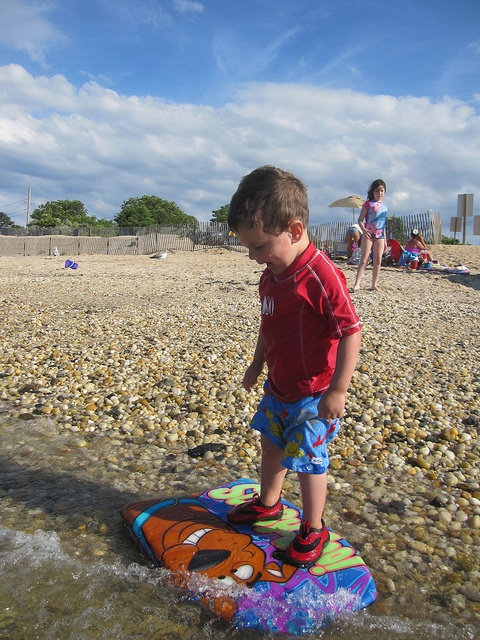Describe the objects in this image and their specific colors. I can see people in darkgray, maroon, black, gray, and salmon tones, surfboard in darkgray, black, brown, maroon, and blue tones, people in darkgray, gray, brown, and lightpink tones, people in darkgray, maroon, brown, purple, and gray tones, and people in darkgray, maroon, gray, black, and brown tones in this image. 